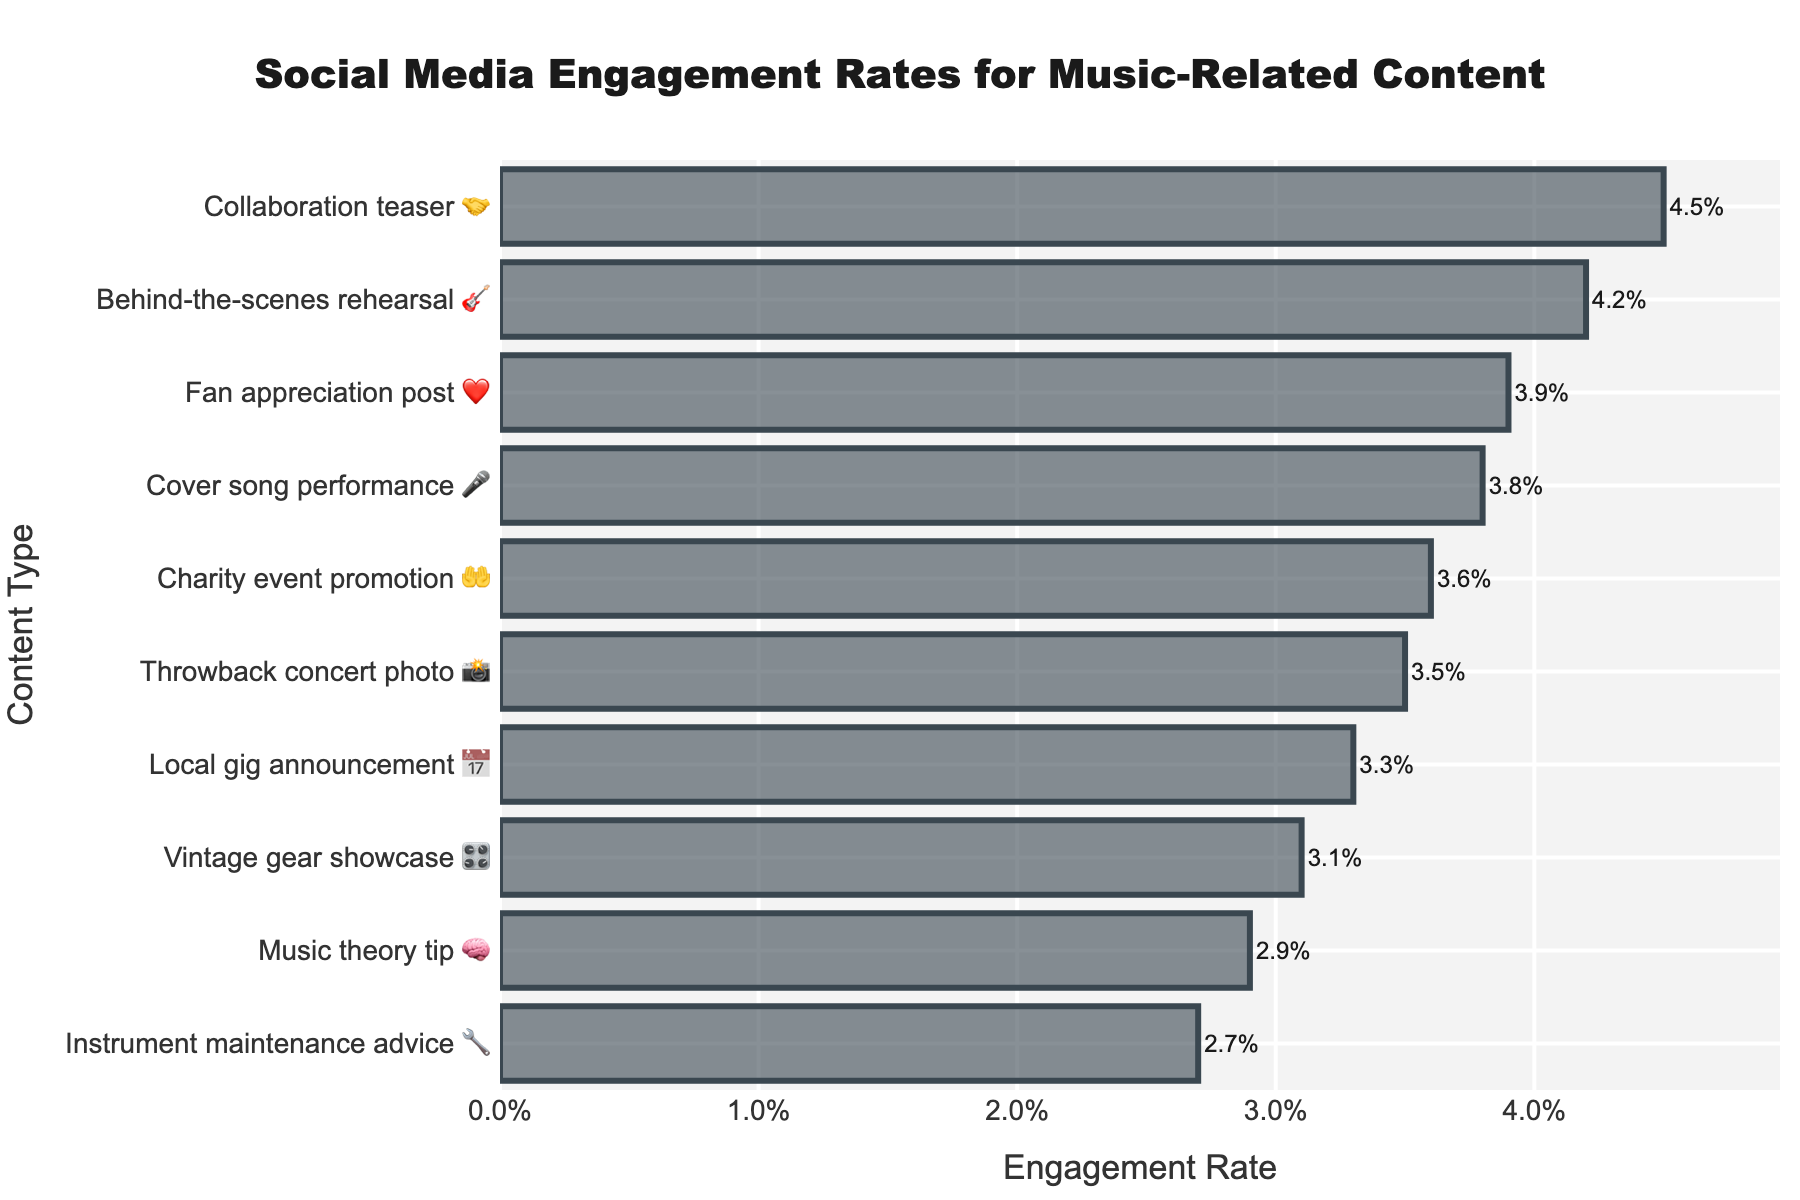what is the highest engagement rate? The highest engagement rate corresponds to the content type listed at the very top of the bar chart.
Answer: Collaboration teaser (4.5%) Which content type has the lowest engagement rate? The lowest engagement rate corresponds to the content type listed at the very bottom of the bar chart.
Answer: Instrument maintenance advice (2.7%) What is the engagement rate for "Fan appreciation post"? Look at the row labeled "Fan appreciation post ❤️" and read the engagement rate value.
Answer: 3.9% Which content type has a higher engagement rate, "Cover song performance" or "Local gig announcement"? Locate both "Cover song performance 🎤" and "Local gig announcement 📅" on the bar chart and compare their engagement rates.
Answer: Cover song performance (3.8%) How much higher is the engagement rate of "Behind-the-scenes rehearsal" compared to "Music theory tip"? Subtract the engagement rate of "Music theory tip 🧠" from "Behind-the-scenes rehearsal 🎸".
Answer: 1.3% What is the average engagement rate of the content types represented in the chart? Sum all the engagement rates and divide by the number of content types: (4.2% + 3.8% + 3.5% + 2.9% + 2.7% + 3.3% + 4.5% + 3.9% + 3.1% + 3.6%) / 10 = 3.55%
Answer: 3.55% Arrange the engagement rates in ascending order for the listed content types. List the engagement rates from the smallest to the largest value.
Answer: 2.7%, 2.9%, 3.1%, 3.3%, 3.5%, 3.6%, 3.8%, 3.9%, 4.2%, 4.5% Which emoji represents the content type with the third highest engagement rate? Find the third highest bar on the chart and look at the associated emoji.
Answer: 📸 (Throwback concert photo) If "Charity event promotion" increased its engagement rate by 1%, what would the new rate be? Add 1% to the current engagement rate of "Charity event promotion 🤲".
Answer: 4.6% How many content types have an engagement rate higher than 4%? Count the number of rows where the engagement rate exceeds 4%.
Answer: 2 